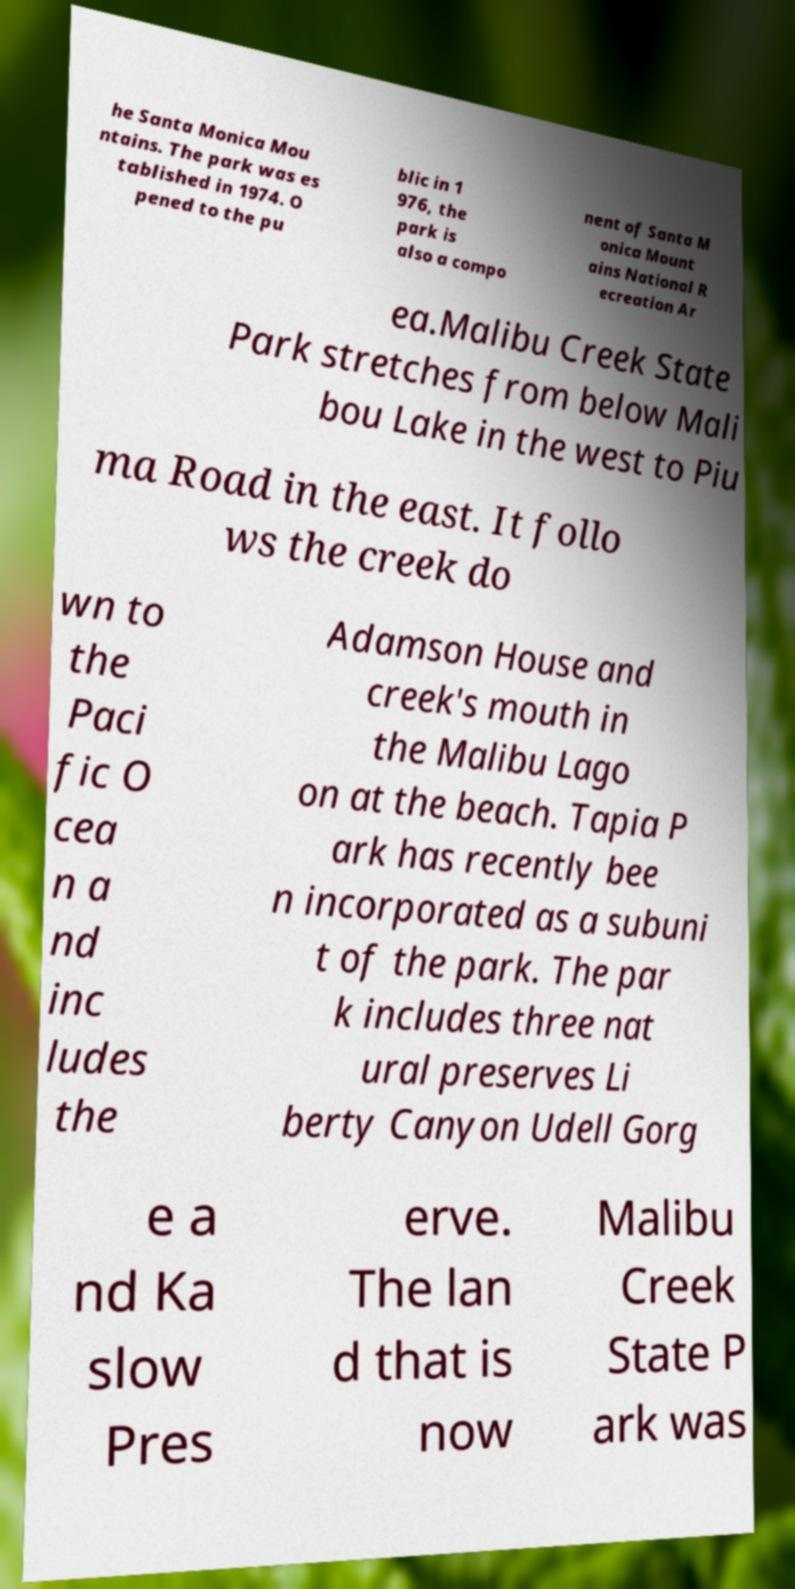Can you read and provide the text displayed in the image?This photo seems to have some interesting text. Can you extract and type it out for me? he Santa Monica Mou ntains. The park was es tablished in 1974. O pened to the pu blic in 1 976, the park is also a compo nent of Santa M onica Mount ains National R ecreation Ar ea.Malibu Creek State Park stretches from below Mali bou Lake in the west to Piu ma Road in the east. It follo ws the creek do wn to the Paci fic O cea n a nd inc ludes the Adamson House and creek's mouth in the Malibu Lago on at the beach. Tapia P ark has recently bee n incorporated as a subuni t of the park. The par k includes three nat ural preserves Li berty Canyon Udell Gorg e a nd Ka slow Pres erve. The lan d that is now Malibu Creek State P ark was 